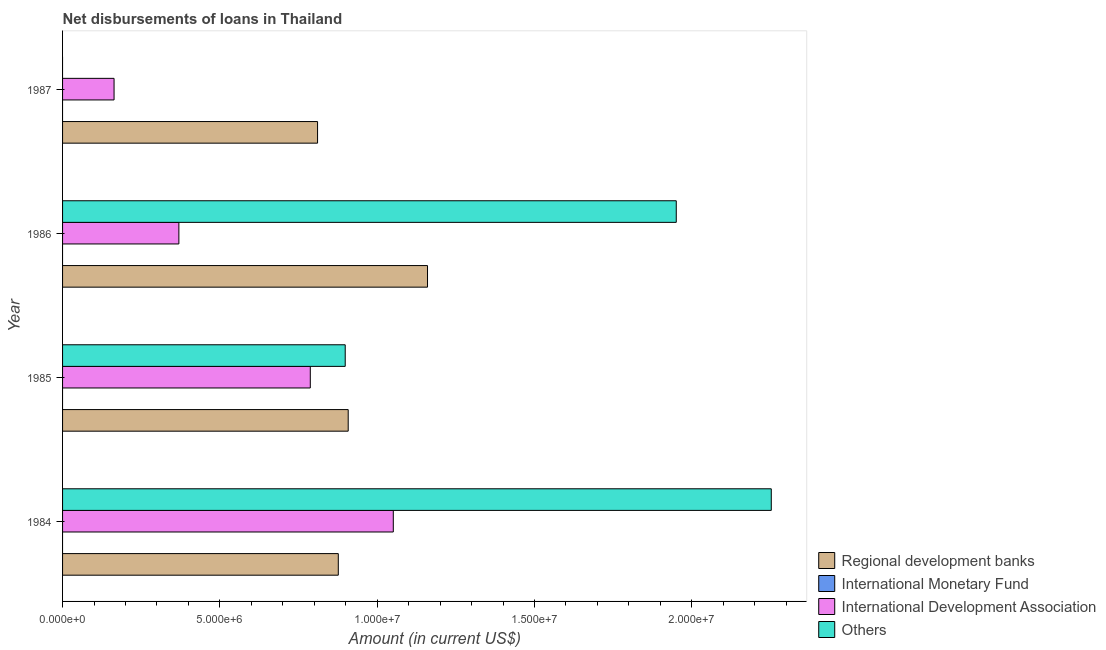Are the number of bars on each tick of the Y-axis equal?
Provide a succinct answer. No. How many bars are there on the 3rd tick from the top?
Ensure brevity in your answer.  3. How many bars are there on the 4th tick from the bottom?
Your response must be concise. 2. What is the amount of loan disimbursed by regional development banks in 1986?
Your answer should be compact. 1.16e+07. Across all years, what is the maximum amount of loan disimbursed by other organisations?
Offer a very short reply. 2.25e+07. Across all years, what is the minimum amount of loan disimbursed by other organisations?
Make the answer very short. 0. What is the total amount of loan disimbursed by other organisations in the graph?
Your answer should be compact. 5.10e+07. What is the difference between the amount of loan disimbursed by other organisations in 1984 and that in 1986?
Provide a short and direct response. 3.02e+06. What is the difference between the amount of loan disimbursed by international monetary fund in 1987 and the amount of loan disimbursed by international development association in 1984?
Keep it short and to the point. -1.05e+07. What is the average amount of loan disimbursed by regional development banks per year?
Offer a terse response. 9.39e+06. In the year 1986, what is the difference between the amount of loan disimbursed by regional development banks and amount of loan disimbursed by international development association?
Offer a very short reply. 7.90e+06. What is the ratio of the amount of loan disimbursed by other organisations in 1984 to that in 1985?
Provide a short and direct response. 2.51. Is the difference between the amount of loan disimbursed by regional development banks in 1985 and 1986 greater than the difference between the amount of loan disimbursed by other organisations in 1985 and 1986?
Your answer should be compact. Yes. What is the difference between the highest and the second highest amount of loan disimbursed by regional development banks?
Give a very brief answer. 2.52e+06. What is the difference between the highest and the lowest amount of loan disimbursed by international development association?
Provide a short and direct response. 8.88e+06. Is the sum of the amount of loan disimbursed by regional development banks in 1984 and 1985 greater than the maximum amount of loan disimbursed by other organisations across all years?
Your response must be concise. No. Is it the case that in every year, the sum of the amount of loan disimbursed by other organisations and amount of loan disimbursed by international development association is greater than the sum of amount of loan disimbursed by international monetary fund and amount of loan disimbursed by regional development banks?
Give a very brief answer. No. How many bars are there?
Offer a terse response. 11. Are all the bars in the graph horizontal?
Your response must be concise. Yes. How many years are there in the graph?
Your response must be concise. 4. What is the difference between two consecutive major ticks on the X-axis?
Ensure brevity in your answer.  5.00e+06. Does the graph contain grids?
Offer a terse response. No. Where does the legend appear in the graph?
Give a very brief answer. Bottom right. What is the title of the graph?
Your response must be concise. Net disbursements of loans in Thailand. What is the label or title of the Y-axis?
Offer a very short reply. Year. What is the Amount (in current US$) in Regional development banks in 1984?
Give a very brief answer. 8.76e+06. What is the Amount (in current US$) of International Development Association in 1984?
Provide a short and direct response. 1.05e+07. What is the Amount (in current US$) of Others in 1984?
Your answer should be compact. 2.25e+07. What is the Amount (in current US$) of Regional development banks in 1985?
Keep it short and to the point. 9.08e+06. What is the Amount (in current US$) in International Monetary Fund in 1985?
Keep it short and to the point. 0. What is the Amount (in current US$) of International Development Association in 1985?
Offer a terse response. 7.87e+06. What is the Amount (in current US$) in Others in 1985?
Provide a succinct answer. 8.98e+06. What is the Amount (in current US$) of Regional development banks in 1986?
Give a very brief answer. 1.16e+07. What is the Amount (in current US$) of International Monetary Fund in 1986?
Your response must be concise. 0. What is the Amount (in current US$) of International Development Association in 1986?
Your answer should be compact. 3.70e+06. What is the Amount (in current US$) in Others in 1986?
Your answer should be very brief. 1.95e+07. What is the Amount (in current US$) in Regional development banks in 1987?
Provide a short and direct response. 8.10e+06. What is the Amount (in current US$) in International Monetary Fund in 1987?
Your answer should be compact. 0. What is the Amount (in current US$) of International Development Association in 1987?
Keep it short and to the point. 1.64e+06. Across all years, what is the maximum Amount (in current US$) in Regional development banks?
Offer a terse response. 1.16e+07. Across all years, what is the maximum Amount (in current US$) in International Development Association?
Offer a terse response. 1.05e+07. Across all years, what is the maximum Amount (in current US$) of Others?
Provide a short and direct response. 2.25e+07. Across all years, what is the minimum Amount (in current US$) in Regional development banks?
Your response must be concise. 8.10e+06. Across all years, what is the minimum Amount (in current US$) in International Development Association?
Provide a short and direct response. 1.64e+06. Across all years, what is the minimum Amount (in current US$) of Others?
Give a very brief answer. 0. What is the total Amount (in current US$) in Regional development banks in the graph?
Offer a terse response. 3.75e+07. What is the total Amount (in current US$) in International Development Association in the graph?
Offer a very short reply. 2.37e+07. What is the total Amount (in current US$) of Others in the graph?
Provide a succinct answer. 5.10e+07. What is the difference between the Amount (in current US$) of Regional development banks in 1984 and that in 1985?
Your answer should be very brief. -3.15e+05. What is the difference between the Amount (in current US$) of International Development Association in 1984 and that in 1985?
Ensure brevity in your answer.  2.64e+06. What is the difference between the Amount (in current US$) of Others in 1984 and that in 1985?
Offer a very short reply. 1.35e+07. What is the difference between the Amount (in current US$) in Regional development banks in 1984 and that in 1986?
Ensure brevity in your answer.  -2.84e+06. What is the difference between the Amount (in current US$) in International Development Association in 1984 and that in 1986?
Offer a very short reply. 6.82e+06. What is the difference between the Amount (in current US$) in Others in 1984 and that in 1986?
Your answer should be very brief. 3.02e+06. What is the difference between the Amount (in current US$) in Regional development banks in 1984 and that in 1987?
Offer a terse response. 6.59e+05. What is the difference between the Amount (in current US$) of International Development Association in 1984 and that in 1987?
Offer a very short reply. 8.88e+06. What is the difference between the Amount (in current US$) in Regional development banks in 1985 and that in 1986?
Offer a terse response. -2.52e+06. What is the difference between the Amount (in current US$) of International Development Association in 1985 and that in 1986?
Keep it short and to the point. 4.18e+06. What is the difference between the Amount (in current US$) in Others in 1985 and that in 1986?
Make the answer very short. -1.05e+07. What is the difference between the Amount (in current US$) of Regional development banks in 1985 and that in 1987?
Ensure brevity in your answer.  9.74e+05. What is the difference between the Amount (in current US$) in International Development Association in 1985 and that in 1987?
Provide a succinct answer. 6.24e+06. What is the difference between the Amount (in current US$) of Regional development banks in 1986 and that in 1987?
Your answer should be very brief. 3.50e+06. What is the difference between the Amount (in current US$) in International Development Association in 1986 and that in 1987?
Your answer should be very brief. 2.06e+06. What is the difference between the Amount (in current US$) in Regional development banks in 1984 and the Amount (in current US$) in International Development Association in 1985?
Offer a very short reply. 8.90e+05. What is the difference between the Amount (in current US$) of International Development Association in 1984 and the Amount (in current US$) of Others in 1985?
Provide a succinct answer. 1.53e+06. What is the difference between the Amount (in current US$) in Regional development banks in 1984 and the Amount (in current US$) in International Development Association in 1986?
Your response must be concise. 5.07e+06. What is the difference between the Amount (in current US$) in Regional development banks in 1984 and the Amount (in current US$) in Others in 1986?
Provide a succinct answer. -1.07e+07. What is the difference between the Amount (in current US$) in International Development Association in 1984 and the Amount (in current US$) in Others in 1986?
Provide a succinct answer. -8.99e+06. What is the difference between the Amount (in current US$) in Regional development banks in 1984 and the Amount (in current US$) in International Development Association in 1987?
Provide a succinct answer. 7.13e+06. What is the difference between the Amount (in current US$) in Regional development banks in 1985 and the Amount (in current US$) in International Development Association in 1986?
Provide a short and direct response. 5.38e+06. What is the difference between the Amount (in current US$) of Regional development banks in 1985 and the Amount (in current US$) of Others in 1986?
Your answer should be compact. -1.04e+07. What is the difference between the Amount (in current US$) of International Development Association in 1985 and the Amount (in current US$) of Others in 1986?
Offer a terse response. -1.16e+07. What is the difference between the Amount (in current US$) in Regional development banks in 1985 and the Amount (in current US$) in International Development Association in 1987?
Ensure brevity in your answer.  7.44e+06. What is the difference between the Amount (in current US$) in Regional development banks in 1986 and the Amount (in current US$) in International Development Association in 1987?
Offer a very short reply. 9.96e+06. What is the average Amount (in current US$) of Regional development banks per year?
Provide a short and direct response. 9.39e+06. What is the average Amount (in current US$) in International Monetary Fund per year?
Make the answer very short. 0. What is the average Amount (in current US$) in International Development Association per year?
Offer a very short reply. 5.93e+06. What is the average Amount (in current US$) of Others per year?
Ensure brevity in your answer.  1.28e+07. In the year 1984, what is the difference between the Amount (in current US$) of Regional development banks and Amount (in current US$) of International Development Association?
Your response must be concise. -1.75e+06. In the year 1984, what is the difference between the Amount (in current US$) of Regional development banks and Amount (in current US$) of Others?
Make the answer very short. -1.38e+07. In the year 1984, what is the difference between the Amount (in current US$) in International Development Association and Amount (in current US$) in Others?
Make the answer very short. -1.20e+07. In the year 1985, what is the difference between the Amount (in current US$) of Regional development banks and Amount (in current US$) of International Development Association?
Offer a very short reply. 1.20e+06. In the year 1985, what is the difference between the Amount (in current US$) of Regional development banks and Amount (in current US$) of Others?
Keep it short and to the point. 9.50e+04. In the year 1985, what is the difference between the Amount (in current US$) of International Development Association and Amount (in current US$) of Others?
Ensure brevity in your answer.  -1.11e+06. In the year 1986, what is the difference between the Amount (in current US$) of Regional development banks and Amount (in current US$) of International Development Association?
Provide a succinct answer. 7.90e+06. In the year 1986, what is the difference between the Amount (in current US$) of Regional development banks and Amount (in current US$) of Others?
Your answer should be compact. -7.91e+06. In the year 1986, what is the difference between the Amount (in current US$) of International Development Association and Amount (in current US$) of Others?
Offer a very short reply. -1.58e+07. In the year 1987, what is the difference between the Amount (in current US$) of Regional development banks and Amount (in current US$) of International Development Association?
Provide a succinct answer. 6.47e+06. What is the ratio of the Amount (in current US$) of Regional development banks in 1984 to that in 1985?
Ensure brevity in your answer.  0.97. What is the ratio of the Amount (in current US$) in International Development Association in 1984 to that in 1985?
Your response must be concise. 1.33. What is the ratio of the Amount (in current US$) in Others in 1984 to that in 1985?
Provide a succinct answer. 2.51. What is the ratio of the Amount (in current US$) in Regional development banks in 1984 to that in 1986?
Ensure brevity in your answer.  0.76. What is the ratio of the Amount (in current US$) in International Development Association in 1984 to that in 1986?
Your answer should be compact. 2.84. What is the ratio of the Amount (in current US$) in Others in 1984 to that in 1986?
Provide a succinct answer. 1.15. What is the ratio of the Amount (in current US$) in Regional development banks in 1984 to that in 1987?
Offer a very short reply. 1.08. What is the ratio of the Amount (in current US$) in International Development Association in 1984 to that in 1987?
Provide a succinct answer. 6.42. What is the ratio of the Amount (in current US$) in Regional development banks in 1985 to that in 1986?
Your answer should be compact. 0.78. What is the ratio of the Amount (in current US$) in International Development Association in 1985 to that in 1986?
Keep it short and to the point. 2.13. What is the ratio of the Amount (in current US$) of Others in 1985 to that in 1986?
Give a very brief answer. 0.46. What is the ratio of the Amount (in current US$) of Regional development banks in 1985 to that in 1987?
Your response must be concise. 1.12. What is the ratio of the Amount (in current US$) in International Development Association in 1985 to that in 1987?
Your answer should be compact. 4.81. What is the ratio of the Amount (in current US$) in Regional development banks in 1986 to that in 1987?
Your answer should be very brief. 1.43. What is the ratio of the Amount (in current US$) in International Development Association in 1986 to that in 1987?
Make the answer very short. 2.26. What is the difference between the highest and the second highest Amount (in current US$) in Regional development banks?
Make the answer very short. 2.52e+06. What is the difference between the highest and the second highest Amount (in current US$) of International Development Association?
Provide a succinct answer. 2.64e+06. What is the difference between the highest and the second highest Amount (in current US$) of Others?
Your response must be concise. 3.02e+06. What is the difference between the highest and the lowest Amount (in current US$) of Regional development banks?
Offer a terse response. 3.50e+06. What is the difference between the highest and the lowest Amount (in current US$) of International Development Association?
Your answer should be very brief. 8.88e+06. What is the difference between the highest and the lowest Amount (in current US$) in Others?
Offer a very short reply. 2.25e+07. 